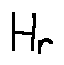<formula> <loc_0><loc_0><loc_500><loc_500>H _ { r }</formula> 